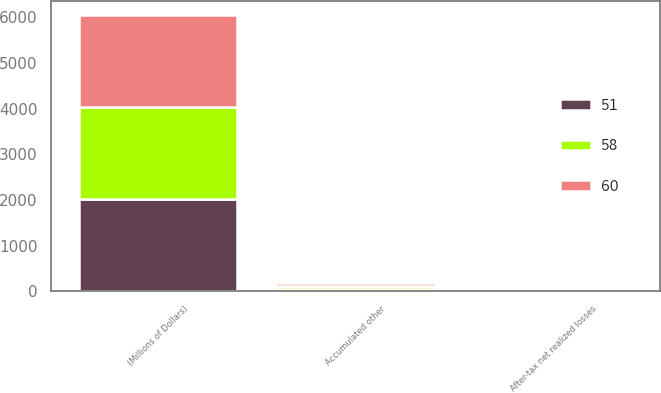Convert chart to OTSL. <chart><loc_0><loc_0><loc_500><loc_500><stacked_bar_chart><ecel><fcel>(Millions of Dollars)<fcel>Accumulated other<fcel>After-tax net realized losses<nl><fcel>58<fcel>2018<fcel>60<fcel>3<nl><fcel>60<fcel>2017<fcel>58<fcel>3<nl><fcel>51<fcel>2016<fcel>51<fcel>4<nl></chart> 